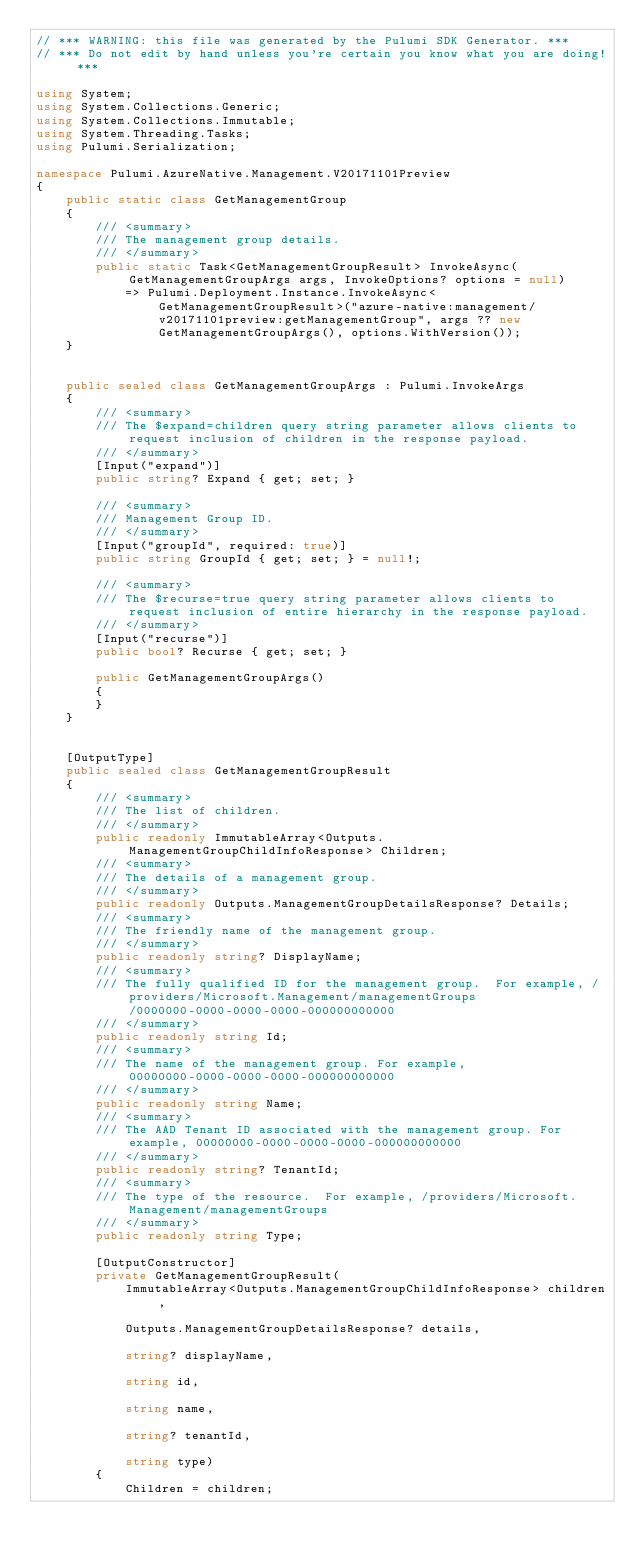<code> <loc_0><loc_0><loc_500><loc_500><_C#_>// *** WARNING: this file was generated by the Pulumi SDK Generator. ***
// *** Do not edit by hand unless you're certain you know what you are doing! ***

using System;
using System.Collections.Generic;
using System.Collections.Immutable;
using System.Threading.Tasks;
using Pulumi.Serialization;

namespace Pulumi.AzureNative.Management.V20171101Preview
{
    public static class GetManagementGroup
    {
        /// <summary>
        /// The management group details.
        /// </summary>
        public static Task<GetManagementGroupResult> InvokeAsync(GetManagementGroupArgs args, InvokeOptions? options = null)
            => Pulumi.Deployment.Instance.InvokeAsync<GetManagementGroupResult>("azure-native:management/v20171101preview:getManagementGroup", args ?? new GetManagementGroupArgs(), options.WithVersion());
    }


    public sealed class GetManagementGroupArgs : Pulumi.InvokeArgs
    {
        /// <summary>
        /// The $expand=children query string parameter allows clients to request inclusion of children in the response payload.
        /// </summary>
        [Input("expand")]
        public string? Expand { get; set; }

        /// <summary>
        /// Management Group ID.
        /// </summary>
        [Input("groupId", required: true)]
        public string GroupId { get; set; } = null!;

        /// <summary>
        /// The $recurse=true query string parameter allows clients to request inclusion of entire hierarchy in the response payload.
        /// </summary>
        [Input("recurse")]
        public bool? Recurse { get; set; }

        public GetManagementGroupArgs()
        {
        }
    }


    [OutputType]
    public sealed class GetManagementGroupResult
    {
        /// <summary>
        /// The list of children.
        /// </summary>
        public readonly ImmutableArray<Outputs.ManagementGroupChildInfoResponse> Children;
        /// <summary>
        /// The details of a management group.
        /// </summary>
        public readonly Outputs.ManagementGroupDetailsResponse? Details;
        /// <summary>
        /// The friendly name of the management group.
        /// </summary>
        public readonly string? DisplayName;
        /// <summary>
        /// The fully qualified ID for the management group.  For example, /providers/Microsoft.Management/managementGroups/0000000-0000-0000-0000-000000000000
        /// </summary>
        public readonly string Id;
        /// <summary>
        /// The name of the management group. For example, 00000000-0000-0000-0000-000000000000
        /// </summary>
        public readonly string Name;
        /// <summary>
        /// The AAD Tenant ID associated with the management group. For example, 00000000-0000-0000-0000-000000000000
        /// </summary>
        public readonly string? TenantId;
        /// <summary>
        /// The type of the resource.  For example, /providers/Microsoft.Management/managementGroups
        /// </summary>
        public readonly string Type;

        [OutputConstructor]
        private GetManagementGroupResult(
            ImmutableArray<Outputs.ManagementGroupChildInfoResponse> children,

            Outputs.ManagementGroupDetailsResponse? details,

            string? displayName,

            string id,

            string name,

            string? tenantId,

            string type)
        {
            Children = children;</code> 